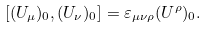Convert formula to latex. <formula><loc_0><loc_0><loc_500><loc_500>[ ( U _ { \mu } ) _ { 0 } , ( U _ { \nu } ) _ { 0 } ] = \varepsilon _ { \mu \nu \rho } ( U ^ { \rho } ) _ { 0 } .</formula> 